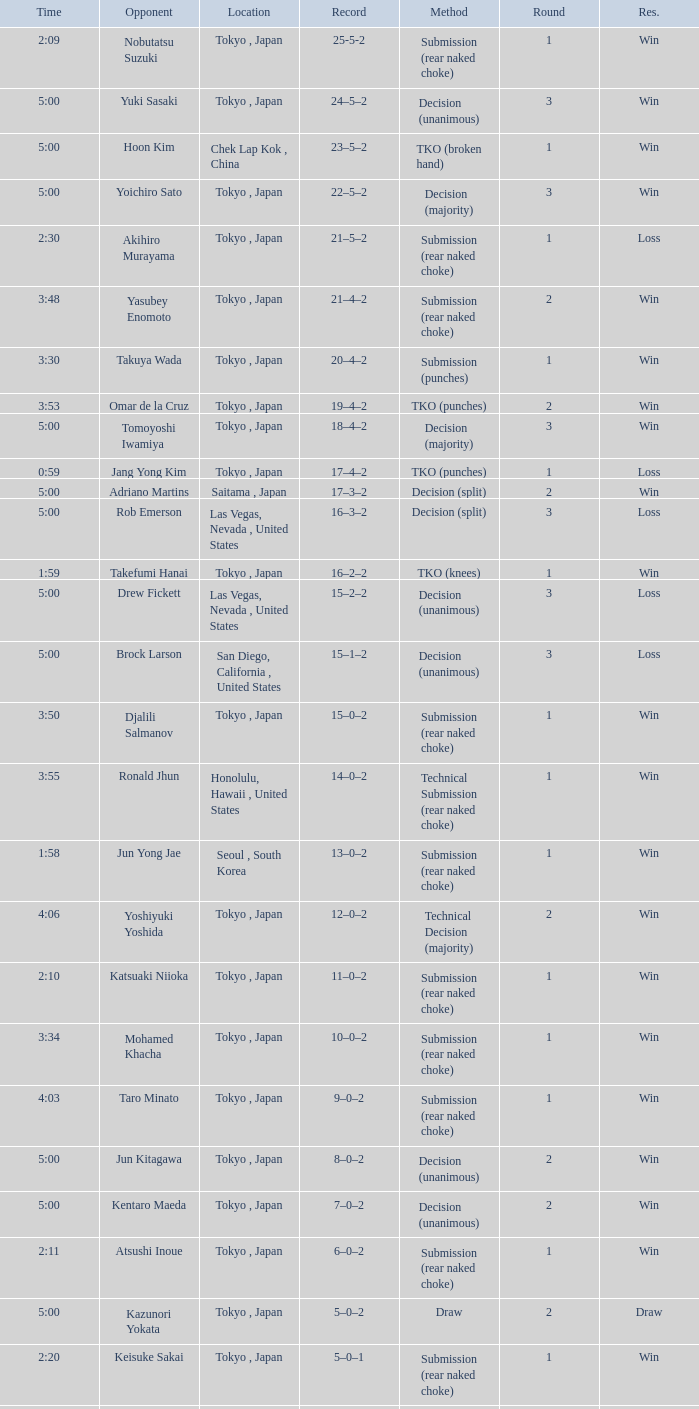What is the total number of rounds when Drew Fickett was the opponent and the time is 5:00? 1.0. 